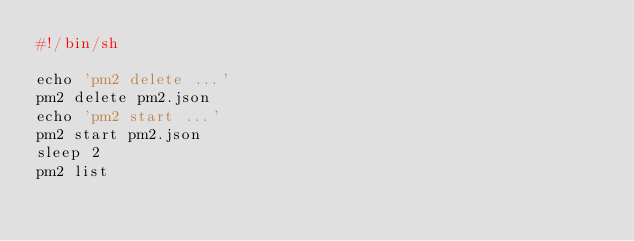Convert code to text. <code><loc_0><loc_0><loc_500><loc_500><_Bash_>#!/bin/sh

echo 'pm2 delete ...'
pm2 delete pm2.json
echo 'pm2 start ...'
pm2 start pm2.json
sleep 2
pm2 list
</code> 